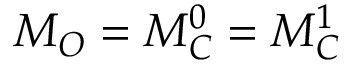<formula> <loc_0><loc_0><loc_500><loc_500>M _ { O } = M _ { C } ^ { 0 } = M _ { C } ^ { 1 }</formula> 